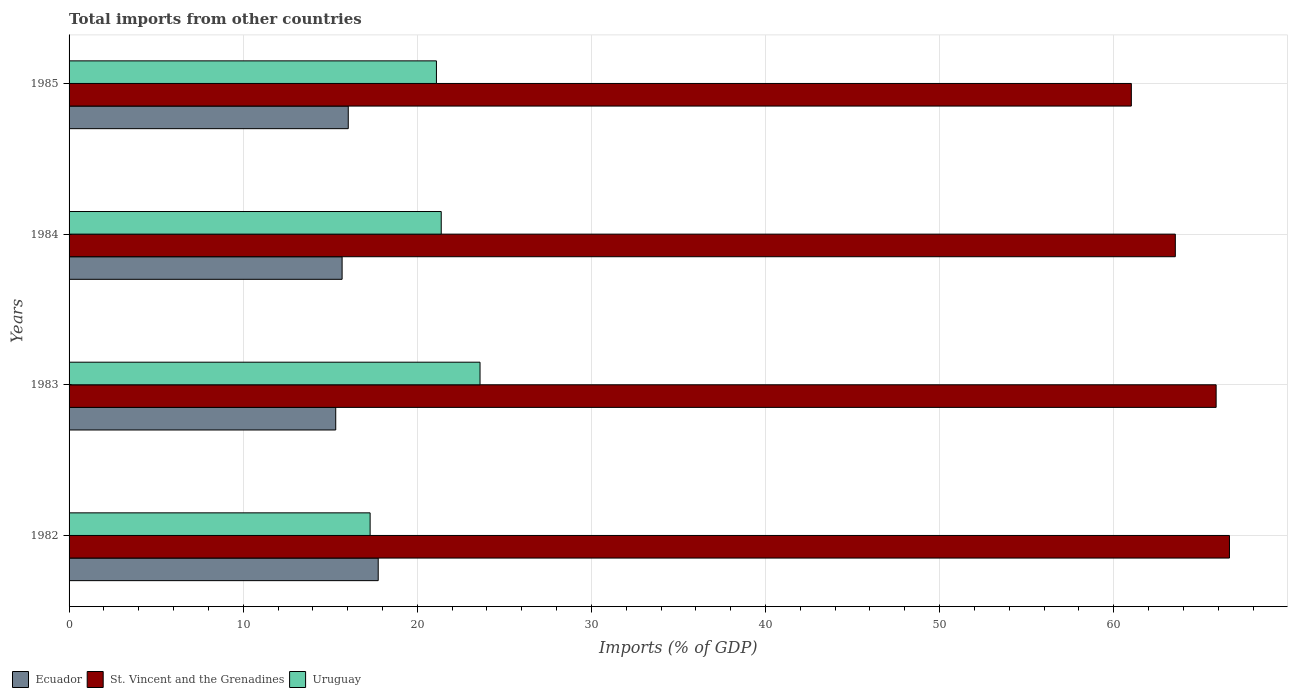How many different coloured bars are there?
Offer a very short reply. 3. How many groups of bars are there?
Offer a terse response. 4. Are the number of bars per tick equal to the number of legend labels?
Provide a succinct answer. Yes. Are the number of bars on each tick of the Y-axis equal?
Provide a short and direct response. Yes. How many bars are there on the 4th tick from the top?
Your answer should be very brief. 3. How many bars are there on the 1st tick from the bottom?
Your response must be concise. 3. What is the label of the 4th group of bars from the top?
Provide a short and direct response. 1982. In how many cases, is the number of bars for a given year not equal to the number of legend labels?
Ensure brevity in your answer.  0. What is the total imports in Uruguay in 1984?
Offer a terse response. 21.38. Across all years, what is the maximum total imports in Uruguay?
Your answer should be very brief. 23.6. Across all years, what is the minimum total imports in Uruguay?
Your response must be concise. 17.29. In which year was the total imports in St. Vincent and the Grenadines maximum?
Ensure brevity in your answer.  1982. In which year was the total imports in Uruguay minimum?
Your answer should be compact. 1982. What is the total total imports in Uruguay in the graph?
Provide a short and direct response. 83.37. What is the difference between the total imports in Ecuador in 1983 and that in 1984?
Offer a terse response. -0.37. What is the difference between the total imports in St. Vincent and the Grenadines in 1985 and the total imports in Uruguay in 1982?
Offer a very short reply. 43.72. What is the average total imports in St. Vincent and the Grenadines per year?
Your answer should be compact. 64.27. In the year 1984, what is the difference between the total imports in Ecuador and total imports in Uruguay?
Offer a terse response. -5.69. In how many years, is the total imports in St. Vincent and the Grenadines greater than 66 %?
Offer a terse response. 1. What is the ratio of the total imports in Uruguay in 1983 to that in 1985?
Your answer should be compact. 1.12. Is the difference between the total imports in Ecuador in 1983 and 1985 greater than the difference between the total imports in Uruguay in 1983 and 1985?
Your response must be concise. No. What is the difference between the highest and the second highest total imports in Ecuador?
Give a very brief answer. 1.72. What is the difference between the highest and the lowest total imports in Ecuador?
Ensure brevity in your answer.  2.44. In how many years, is the total imports in Uruguay greater than the average total imports in Uruguay taken over all years?
Your response must be concise. 3. Is the sum of the total imports in Ecuador in 1984 and 1985 greater than the maximum total imports in Uruguay across all years?
Make the answer very short. Yes. What does the 1st bar from the top in 1983 represents?
Your answer should be very brief. Uruguay. What does the 2nd bar from the bottom in 1984 represents?
Provide a succinct answer. St. Vincent and the Grenadines. How many bars are there?
Offer a terse response. 12. Are all the bars in the graph horizontal?
Provide a short and direct response. Yes. What is the difference between two consecutive major ticks on the X-axis?
Offer a terse response. 10. Does the graph contain any zero values?
Ensure brevity in your answer.  No. How many legend labels are there?
Offer a terse response. 3. What is the title of the graph?
Offer a terse response. Total imports from other countries. Does "Moldova" appear as one of the legend labels in the graph?
Make the answer very short. No. What is the label or title of the X-axis?
Offer a terse response. Imports (% of GDP). What is the Imports (% of GDP) in Ecuador in 1982?
Make the answer very short. 17.76. What is the Imports (% of GDP) of St. Vincent and the Grenadines in 1982?
Provide a succinct answer. 66.65. What is the Imports (% of GDP) in Uruguay in 1982?
Your answer should be compact. 17.29. What is the Imports (% of GDP) of Ecuador in 1983?
Provide a succinct answer. 15.32. What is the Imports (% of GDP) in St. Vincent and the Grenadines in 1983?
Provide a short and direct response. 65.88. What is the Imports (% of GDP) in Uruguay in 1983?
Give a very brief answer. 23.6. What is the Imports (% of GDP) in Ecuador in 1984?
Give a very brief answer. 15.68. What is the Imports (% of GDP) in St. Vincent and the Grenadines in 1984?
Provide a short and direct response. 63.54. What is the Imports (% of GDP) in Uruguay in 1984?
Offer a terse response. 21.38. What is the Imports (% of GDP) in Ecuador in 1985?
Provide a succinct answer. 16.04. What is the Imports (% of GDP) in St. Vincent and the Grenadines in 1985?
Give a very brief answer. 61.01. What is the Imports (% of GDP) of Uruguay in 1985?
Your answer should be very brief. 21.1. Across all years, what is the maximum Imports (% of GDP) in Ecuador?
Your answer should be compact. 17.76. Across all years, what is the maximum Imports (% of GDP) in St. Vincent and the Grenadines?
Your answer should be very brief. 66.65. Across all years, what is the maximum Imports (% of GDP) of Uruguay?
Ensure brevity in your answer.  23.6. Across all years, what is the minimum Imports (% of GDP) of Ecuador?
Your answer should be compact. 15.32. Across all years, what is the minimum Imports (% of GDP) of St. Vincent and the Grenadines?
Provide a succinct answer. 61.01. Across all years, what is the minimum Imports (% of GDP) of Uruguay?
Offer a terse response. 17.29. What is the total Imports (% of GDP) in Ecuador in the graph?
Your answer should be compact. 64.79. What is the total Imports (% of GDP) of St. Vincent and the Grenadines in the graph?
Offer a terse response. 257.08. What is the total Imports (% of GDP) in Uruguay in the graph?
Offer a very short reply. 83.37. What is the difference between the Imports (% of GDP) in Ecuador in 1982 and that in 1983?
Give a very brief answer. 2.44. What is the difference between the Imports (% of GDP) of St. Vincent and the Grenadines in 1982 and that in 1983?
Offer a very short reply. 0.77. What is the difference between the Imports (% of GDP) of Uruguay in 1982 and that in 1983?
Your answer should be very brief. -6.31. What is the difference between the Imports (% of GDP) of Ecuador in 1982 and that in 1984?
Keep it short and to the point. 2.07. What is the difference between the Imports (% of GDP) of St. Vincent and the Grenadines in 1982 and that in 1984?
Give a very brief answer. 3.11. What is the difference between the Imports (% of GDP) of Uruguay in 1982 and that in 1984?
Keep it short and to the point. -4.08. What is the difference between the Imports (% of GDP) in Ecuador in 1982 and that in 1985?
Provide a succinct answer. 1.72. What is the difference between the Imports (% of GDP) in St. Vincent and the Grenadines in 1982 and that in 1985?
Your answer should be compact. 5.64. What is the difference between the Imports (% of GDP) of Uruguay in 1982 and that in 1985?
Your answer should be very brief. -3.81. What is the difference between the Imports (% of GDP) of Ecuador in 1983 and that in 1984?
Your answer should be compact. -0.37. What is the difference between the Imports (% of GDP) of St. Vincent and the Grenadines in 1983 and that in 1984?
Your answer should be very brief. 2.34. What is the difference between the Imports (% of GDP) of Uruguay in 1983 and that in 1984?
Your answer should be very brief. 2.23. What is the difference between the Imports (% of GDP) in Ecuador in 1983 and that in 1985?
Give a very brief answer. -0.72. What is the difference between the Imports (% of GDP) of St. Vincent and the Grenadines in 1983 and that in 1985?
Provide a short and direct response. 4.87. What is the difference between the Imports (% of GDP) of Uruguay in 1983 and that in 1985?
Provide a short and direct response. 2.5. What is the difference between the Imports (% of GDP) of Ecuador in 1984 and that in 1985?
Your response must be concise. -0.35. What is the difference between the Imports (% of GDP) in St. Vincent and the Grenadines in 1984 and that in 1985?
Ensure brevity in your answer.  2.53. What is the difference between the Imports (% of GDP) of Uruguay in 1984 and that in 1985?
Your answer should be compact. 0.28. What is the difference between the Imports (% of GDP) in Ecuador in 1982 and the Imports (% of GDP) in St. Vincent and the Grenadines in 1983?
Ensure brevity in your answer.  -48.13. What is the difference between the Imports (% of GDP) of Ecuador in 1982 and the Imports (% of GDP) of Uruguay in 1983?
Ensure brevity in your answer.  -5.85. What is the difference between the Imports (% of GDP) of St. Vincent and the Grenadines in 1982 and the Imports (% of GDP) of Uruguay in 1983?
Keep it short and to the point. 43.04. What is the difference between the Imports (% of GDP) of Ecuador in 1982 and the Imports (% of GDP) of St. Vincent and the Grenadines in 1984?
Your answer should be compact. -45.78. What is the difference between the Imports (% of GDP) in Ecuador in 1982 and the Imports (% of GDP) in Uruguay in 1984?
Keep it short and to the point. -3.62. What is the difference between the Imports (% of GDP) of St. Vincent and the Grenadines in 1982 and the Imports (% of GDP) of Uruguay in 1984?
Provide a short and direct response. 45.27. What is the difference between the Imports (% of GDP) in Ecuador in 1982 and the Imports (% of GDP) in St. Vincent and the Grenadines in 1985?
Offer a terse response. -43.26. What is the difference between the Imports (% of GDP) of Ecuador in 1982 and the Imports (% of GDP) of Uruguay in 1985?
Your answer should be very brief. -3.34. What is the difference between the Imports (% of GDP) in St. Vincent and the Grenadines in 1982 and the Imports (% of GDP) in Uruguay in 1985?
Your answer should be very brief. 45.55. What is the difference between the Imports (% of GDP) of Ecuador in 1983 and the Imports (% of GDP) of St. Vincent and the Grenadines in 1984?
Give a very brief answer. -48.22. What is the difference between the Imports (% of GDP) of Ecuador in 1983 and the Imports (% of GDP) of Uruguay in 1984?
Provide a short and direct response. -6.06. What is the difference between the Imports (% of GDP) in St. Vincent and the Grenadines in 1983 and the Imports (% of GDP) in Uruguay in 1984?
Offer a very short reply. 44.51. What is the difference between the Imports (% of GDP) of Ecuador in 1983 and the Imports (% of GDP) of St. Vincent and the Grenadines in 1985?
Give a very brief answer. -45.7. What is the difference between the Imports (% of GDP) of Ecuador in 1983 and the Imports (% of GDP) of Uruguay in 1985?
Ensure brevity in your answer.  -5.78. What is the difference between the Imports (% of GDP) in St. Vincent and the Grenadines in 1983 and the Imports (% of GDP) in Uruguay in 1985?
Provide a short and direct response. 44.78. What is the difference between the Imports (% of GDP) of Ecuador in 1984 and the Imports (% of GDP) of St. Vincent and the Grenadines in 1985?
Provide a succinct answer. -45.33. What is the difference between the Imports (% of GDP) in Ecuador in 1984 and the Imports (% of GDP) in Uruguay in 1985?
Offer a very short reply. -5.42. What is the difference between the Imports (% of GDP) in St. Vincent and the Grenadines in 1984 and the Imports (% of GDP) in Uruguay in 1985?
Ensure brevity in your answer.  42.44. What is the average Imports (% of GDP) in Ecuador per year?
Provide a short and direct response. 16.2. What is the average Imports (% of GDP) in St. Vincent and the Grenadines per year?
Give a very brief answer. 64.27. What is the average Imports (% of GDP) of Uruguay per year?
Provide a short and direct response. 20.84. In the year 1982, what is the difference between the Imports (% of GDP) of Ecuador and Imports (% of GDP) of St. Vincent and the Grenadines?
Your answer should be compact. -48.89. In the year 1982, what is the difference between the Imports (% of GDP) of Ecuador and Imports (% of GDP) of Uruguay?
Offer a very short reply. 0.47. In the year 1982, what is the difference between the Imports (% of GDP) in St. Vincent and the Grenadines and Imports (% of GDP) in Uruguay?
Keep it short and to the point. 49.36. In the year 1983, what is the difference between the Imports (% of GDP) of Ecuador and Imports (% of GDP) of St. Vincent and the Grenadines?
Offer a very short reply. -50.57. In the year 1983, what is the difference between the Imports (% of GDP) of Ecuador and Imports (% of GDP) of Uruguay?
Give a very brief answer. -8.29. In the year 1983, what is the difference between the Imports (% of GDP) of St. Vincent and the Grenadines and Imports (% of GDP) of Uruguay?
Your answer should be very brief. 42.28. In the year 1984, what is the difference between the Imports (% of GDP) in Ecuador and Imports (% of GDP) in St. Vincent and the Grenadines?
Your answer should be very brief. -47.86. In the year 1984, what is the difference between the Imports (% of GDP) in Ecuador and Imports (% of GDP) in Uruguay?
Your response must be concise. -5.69. In the year 1984, what is the difference between the Imports (% of GDP) of St. Vincent and the Grenadines and Imports (% of GDP) of Uruguay?
Your answer should be very brief. 42.16. In the year 1985, what is the difference between the Imports (% of GDP) in Ecuador and Imports (% of GDP) in St. Vincent and the Grenadines?
Offer a very short reply. -44.98. In the year 1985, what is the difference between the Imports (% of GDP) of Ecuador and Imports (% of GDP) of Uruguay?
Offer a very short reply. -5.06. In the year 1985, what is the difference between the Imports (% of GDP) of St. Vincent and the Grenadines and Imports (% of GDP) of Uruguay?
Make the answer very short. 39.91. What is the ratio of the Imports (% of GDP) in Ecuador in 1982 to that in 1983?
Ensure brevity in your answer.  1.16. What is the ratio of the Imports (% of GDP) in St. Vincent and the Grenadines in 1982 to that in 1983?
Provide a short and direct response. 1.01. What is the ratio of the Imports (% of GDP) in Uruguay in 1982 to that in 1983?
Your response must be concise. 0.73. What is the ratio of the Imports (% of GDP) in Ecuador in 1982 to that in 1984?
Provide a succinct answer. 1.13. What is the ratio of the Imports (% of GDP) of St. Vincent and the Grenadines in 1982 to that in 1984?
Provide a succinct answer. 1.05. What is the ratio of the Imports (% of GDP) of Uruguay in 1982 to that in 1984?
Your response must be concise. 0.81. What is the ratio of the Imports (% of GDP) of Ecuador in 1982 to that in 1985?
Ensure brevity in your answer.  1.11. What is the ratio of the Imports (% of GDP) of St. Vincent and the Grenadines in 1982 to that in 1985?
Keep it short and to the point. 1.09. What is the ratio of the Imports (% of GDP) of Uruguay in 1982 to that in 1985?
Give a very brief answer. 0.82. What is the ratio of the Imports (% of GDP) in Ecuador in 1983 to that in 1984?
Give a very brief answer. 0.98. What is the ratio of the Imports (% of GDP) of St. Vincent and the Grenadines in 1983 to that in 1984?
Give a very brief answer. 1.04. What is the ratio of the Imports (% of GDP) of Uruguay in 1983 to that in 1984?
Provide a succinct answer. 1.1. What is the ratio of the Imports (% of GDP) of Ecuador in 1983 to that in 1985?
Your answer should be very brief. 0.96. What is the ratio of the Imports (% of GDP) in St. Vincent and the Grenadines in 1983 to that in 1985?
Keep it short and to the point. 1.08. What is the ratio of the Imports (% of GDP) of Uruguay in 1983 to that in 1985?
Your answer should be compact. 1.12. What is the ratio of the Imports (% of GDP) of Ecuador in 1984 to that in 1985?
Your answer should be very brief. 0.98. What is the ratio of the Imports (% of GDP) of St. Vincent and the Grenadines in 1984 to that in 1985?
Give a very brief answer. 1.04. What is the ratio of the Imports (% of GDP) in Uruguay in 1984 to that in 1985?
Make the answer very short. 1.01. What is the difference between the highest and the second highest Imports (% of GDP) in Ecuador?
Your response must be concise. 1.72. What is the difference between the highest and the second highest Imports (% of GDP) in St. Vincent and the Grenadines?
Give a very brief answer. 0.77. What is the difference between the highest and the second highest Imports (% of GDP) in Uruguay?
Make the answer very short. 2.23. What is the difference between the highest and the lowest Imports (% of GDP) in Ecuador?
Provide a short and direct response. 2.44. What is the difference between the highest and the lowest Imports (% of GDP) in St. Vincent and the Grenadines?
Make the answer very short. 5.64. What is the difference between the highest and the lowest Imports (% of GDP) of Uruguay?
Offer a terse response. 6.31. 